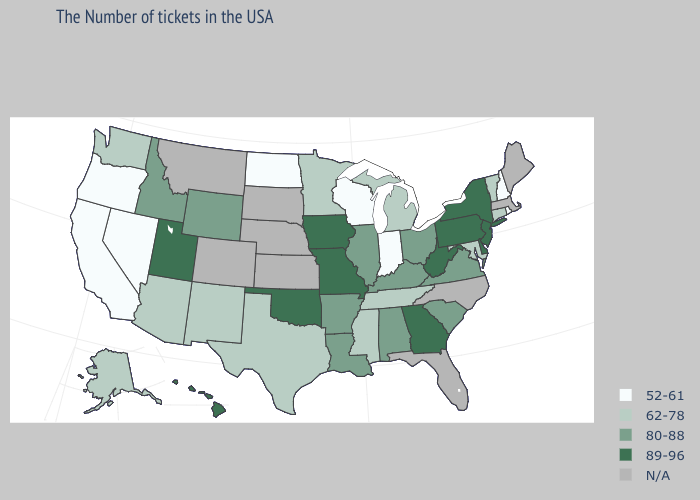Which states have the lowest value in the USA?
Answer briefly. Rhode Island, New Hampshire, Indiana, Wisconsin, North Dakota, Nevada, California, Oregon. Which states hav the highest value in the Northeast?
Concise answer only. New York, New Jersey, Pennsylvania. What is the lowest value in the Northeast?
Concise answer only. 52-61. Name the states that have a value in the range 62-78?
Quick response, please. Vermont, Connecticut, Maryland, Michigan, Tennessee, Mississippi, Minnesota, Texas, New Mexico, Arizona, Washington, Alaska. Among the states that border North Dakota , which have the highest value?
Concise answer only. Minnesota. What is the value of Massachusetts?
Give a very brief answer. N/A. Among the states that border Wisconsin , which have the lowest value?
Give a very brief answer. Michigan, Minnesota. Which states hav the highest value in the West?
Concise answer only. Utah, Hawaii. Does Indiana have the lowest value in the USA?
Write a very short answer. Yes. What is the highest value in states that border Washington?
Be succinct. 80-88. Does the map have missing data?
Concise answer only. Yes. Does the first symbol in the legend represent the smallest category?
Give a very brief answer. Yes. What is the highest value in the West ?
Answer briefly. 89-96. 